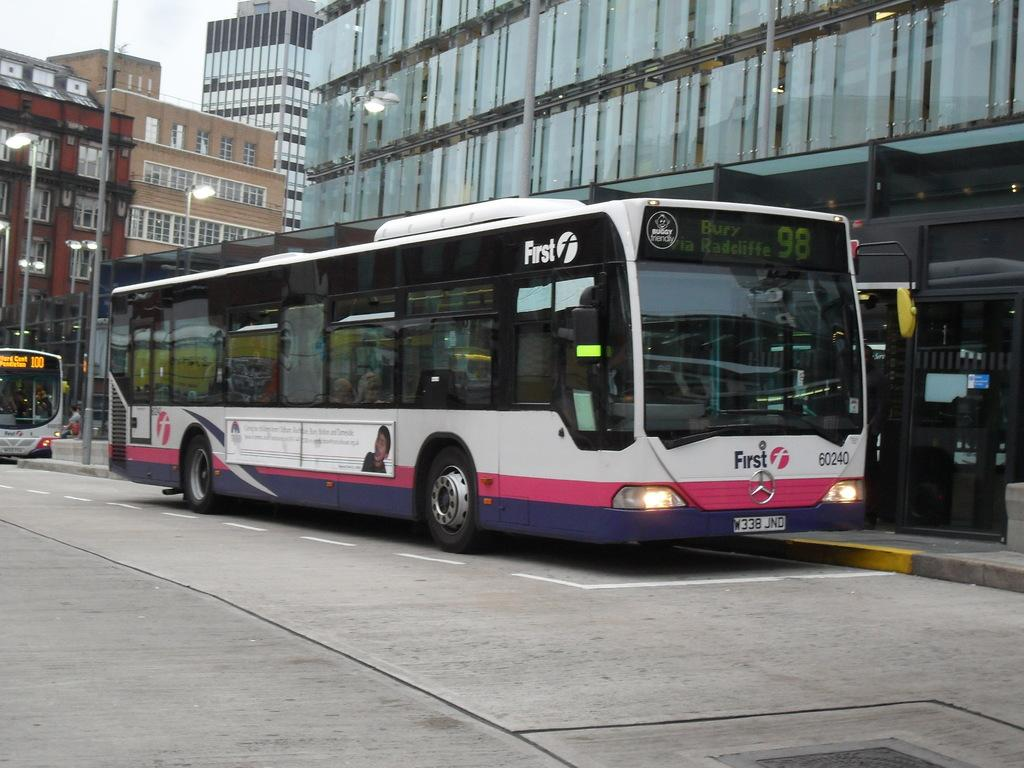<image>
Share a concise interpretation of the image provided. A white,, pink, and purple bus with the license plate W338 JND. 